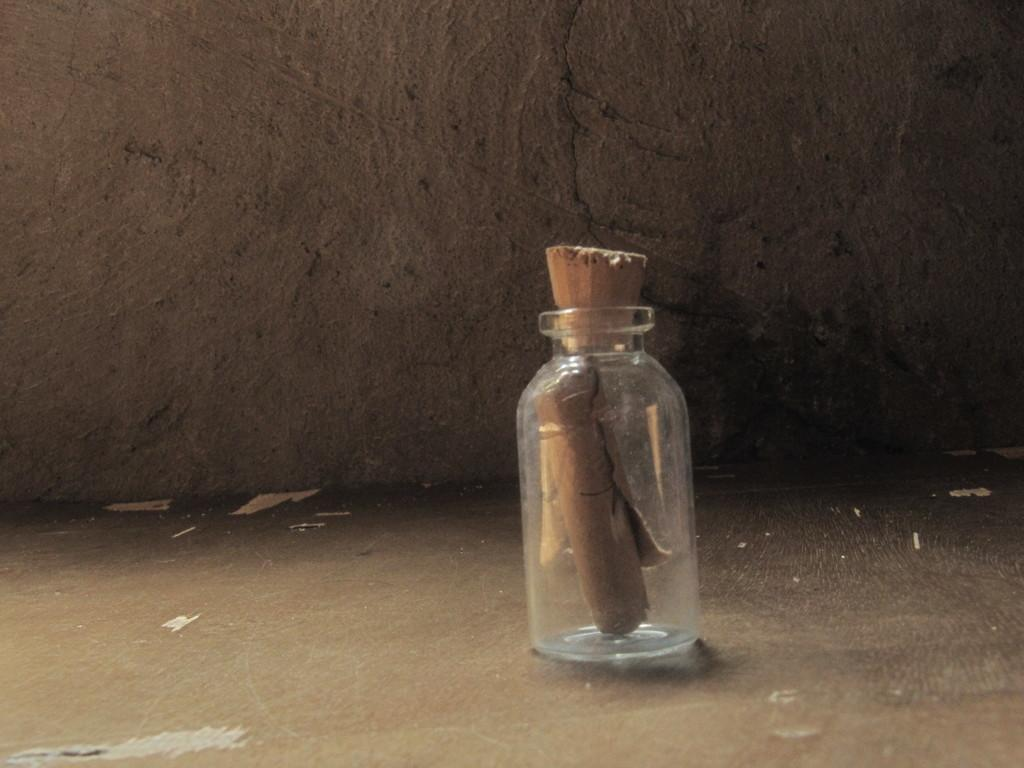What is the main object in the image? There is a glass jar in the image. What is inside the glass jar? A wooden object is inserted in the glass jar. What can be seen in the background of the image? There is a wall in the background of the image. What type of coil is wrapped around the wooden object in the image? There is no coil present in the image; it only features a glass jar with a wooden object inside. 